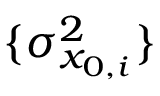<formula> <loc_0><loc_0><loc_500><loc_500>\{ \sigma _ { x _ { 0 , i } } ^ { 2 } \}</formula> 